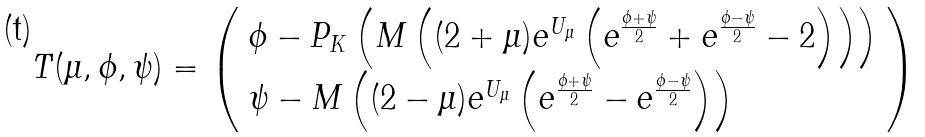Convert formula to latex. <formula><loc_0><loc_0><loc_500><loc_500>T ( \mu , \phi , \psi ) = \left ( \begin{array} { l } \phi - P _ { K } \left ( M \left ( ( 2 + \mu ) e ^ { U _ { \mu } } \left ( e ^ { \frac { \phi + \psi } 2 } + e ^ { \frac { \phi - \psi } 2 } - 2 \right ) \right ) \right ) \\ \psi - M \left ( ( 2 - \mu ) e ^ { U _ { \mu } } \left ( e ^ { \frac { \phi + \psi } 2 } - e ^ { \frac { \phi - \psi } 2 } \right ) \right ) \end{array} \right )</formula> 